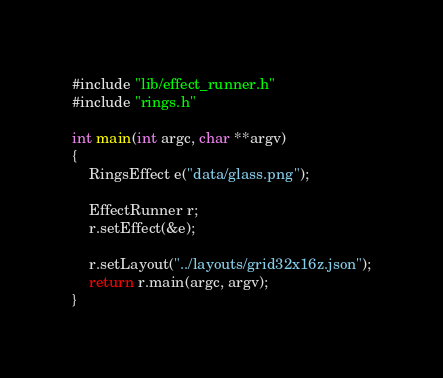<code> <loc_0><loc_0><loc_500><loc_500><_C++_>#include "lib/effect_runner.h"
#include "rings.h"

int main(int argc, char **argv)
{
    RingsEffect e("data/glass.png");

    EffectRunner r;
    r.setEffect(&e);

    r.setLayout("../layouts/grid32x16z.json");
    return r.main(argc, argv);
}
</code> 